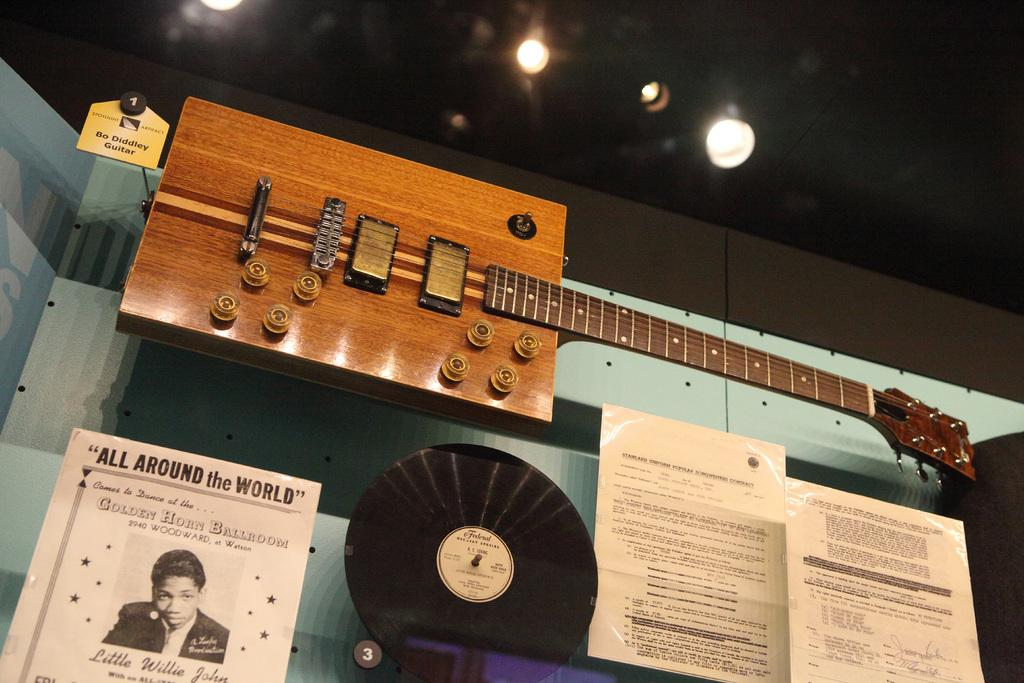What musical instrument is present in the image? There is a guitar in the image. What else can be seen on the wall in the image? There is a poster in the image. What are the papers attached to in the image? The papers are attached to a glass surface in the image. What is visible at the top of the image? Lights are visible at the top of the image. Who is the owner of the guitar in the image? There is no information about the owner of the guitar in the image. What type of milk is being poured into the glass surface with the papers attached? There is no milk present in the image; it features a guitar, a poster, papers attached to a glass surface, and lights. 